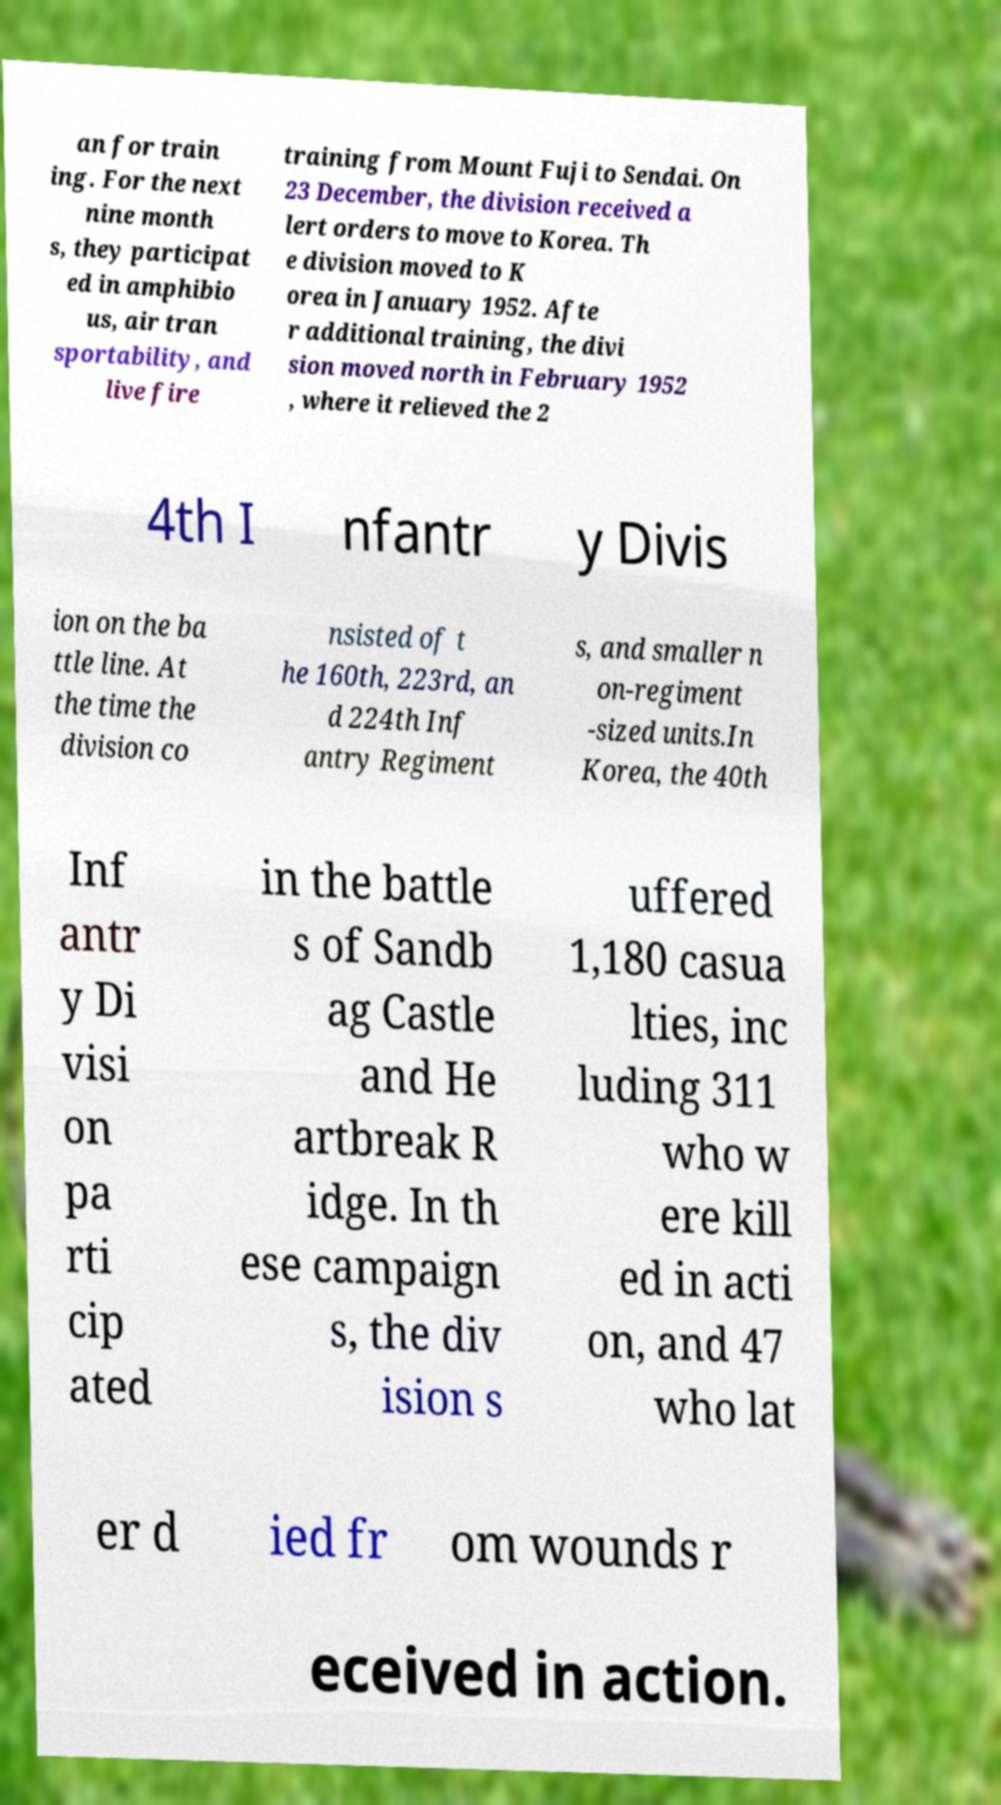There's text embedded in this image that I need extracted. Can you transcribe it verbatim? an for train ing. For the next nine month s, they participat ed in amphibio us, air tran sportability, and live fire training from Mount Fuji to Sendai. On 23 December, the division received a lert orders to move to Korea. Th e division moved to K orea in January 1952. Afte r additional training, the divi sion moved north in February 1952 , where it relieved the 2 4th I nfantr y Divis ion on the ba ttle line. At the time the division co nsisted of t he 160th, 223rd, an d 224th Inf antry Regiment s, and smaller n on-regiment -sized units.In Korea, the 40th Inf antr y Di visi on pa rti cip ated in the battle s of Sandb ag Castle and He artbreak R idge. In th ese campaign s, the div ision s uffered 1,180 casua lties, inc luding 311 who w ere kill ed in acti on, and 47 who lat er d ied fr om wounds r eceived in action. 